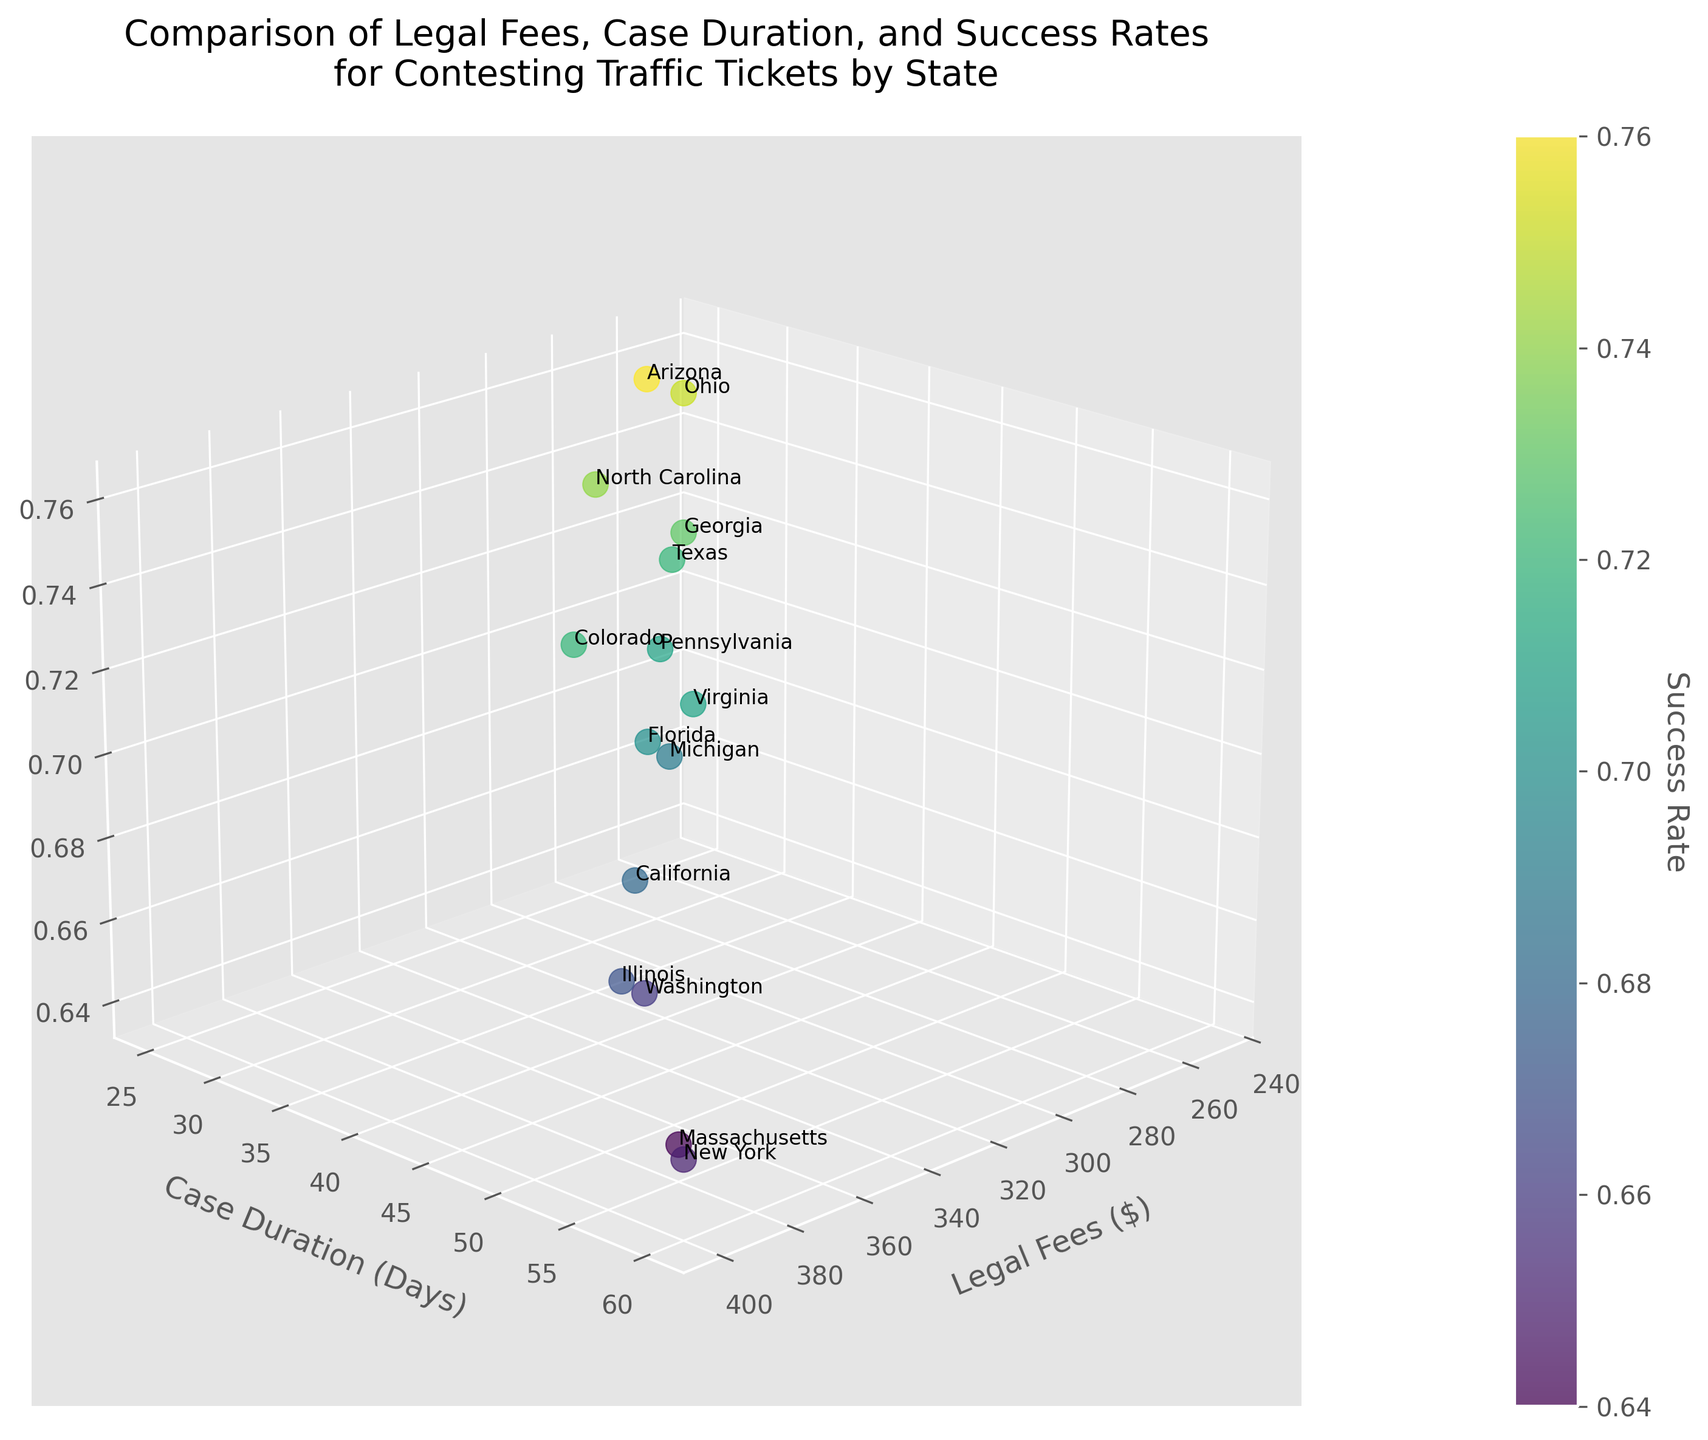What's the title of the figure? Looking at the top of the figure, the title provided describes the comparison of various factors related to traffic tickets.
Answer: Comparison of Legal Fees, Case Duration, and Success Rates for Contesting Traffic Tickets by State How many states are represented in the figure? Count the number of unique data points, each representing a state, in the 3D scatter plot.
Answer: 15 Which state has the highest legal fees? Identify the data point with the highest value on the Legal Fees ($) axis, and check its corresponding label.
Answer: New York What is the relationship between success rate and legal fees for Ohio and Michigan? Observe the positioning of Ohio and Michigan on the Legal Fees ($) axis and Success Rate dimension, noting the differences and similarities. Ohio has lower legal fees and a higher success rate compared to Michigan.
Answer: Ohio has lower fees and higher success Does higher legal fees guarantee a higher success rate? Compare the scatter points' positions across the Legal Fees and Success Rate dimensions; higher fees do not consistently correlate with higher success rates.
Answer: No Between California and Texas, which state has a shorter case duration and higher success rate? Compare their respective data points on both the Case Duration (Days) and Success Rate axes. Texas has a shorter case duration and a higher success rate.
Answer: Texas What is the average legal fee for contesting traffic tickets across all states? Sum the legal fees for all states and divide by the number of states (350+275+400+325+375+300+250+280+310+290+320+360+270+380+330)/15.
Answer: $318.33 Which state has the quickest average case duration? Identify the data point with the lowest value on the Case Duration (Days) axis.
Answer: Ohio Does Florida have a higher success rate than Colorado? Compare the Success Rate values for the data points labeled Florida and Colorado. Florida's success rate is lower.
Answer: No What is the total case duration for New York and Washington combined? Add the case durations of New York and Washington, 60 + 48.
Answer: 108 days 